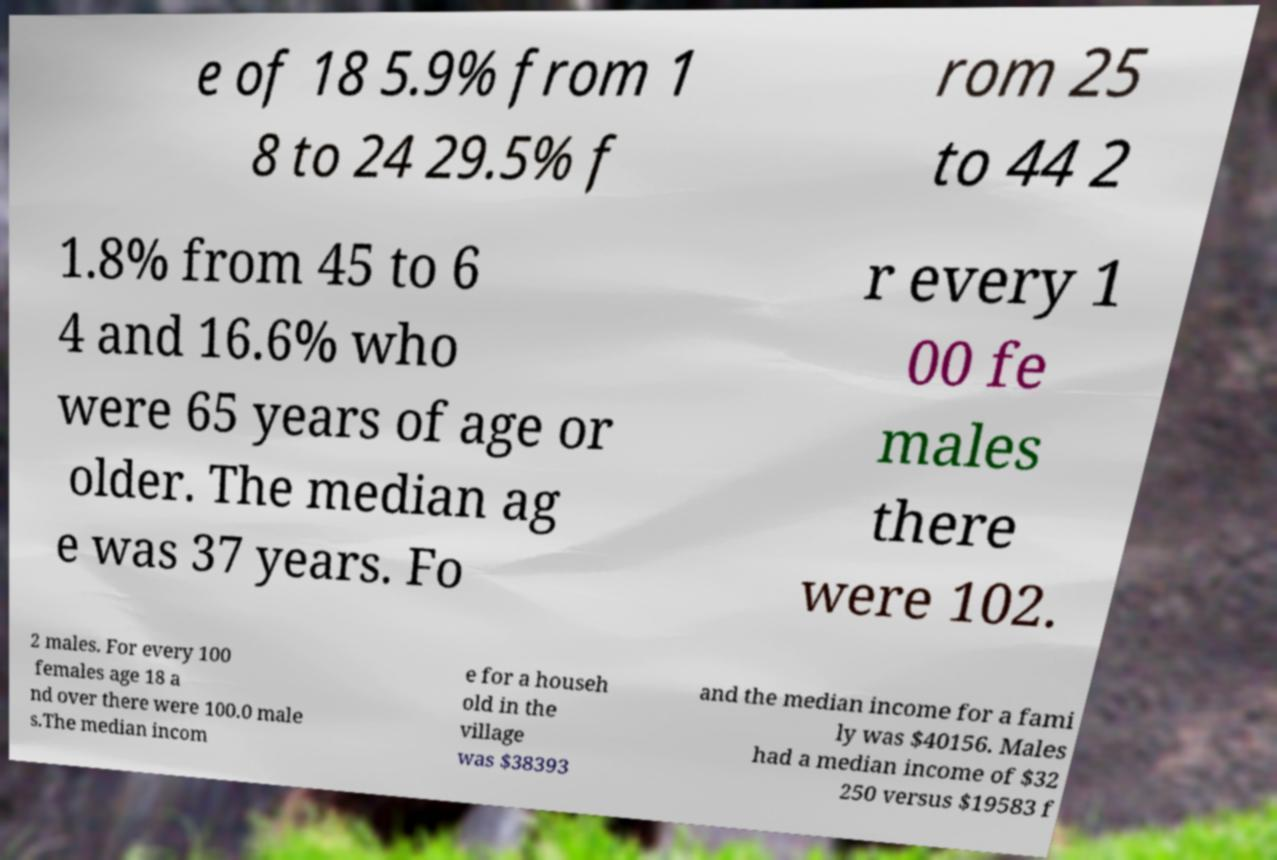Can you read and provide the text displayed in the image?This photo seems to have some interesting text. Can you extract and type it out for me? e of 18 5.9% from 1 8 to 24 29.5% f rom 25 to 44 2 1.8% from 45 to 6 4 and 16.6% who were 65 years of age or older. The median ag e was 37 years. Fo r every 1 00 fe males there were 102. 2 males. For every 100 females age 18 a nd over there were 100.0 male s.The median incom e for a househ old in the village was $38393 and the median income for a fami ly was $40156. Males had a median income of $32 250 versus $19583 f 